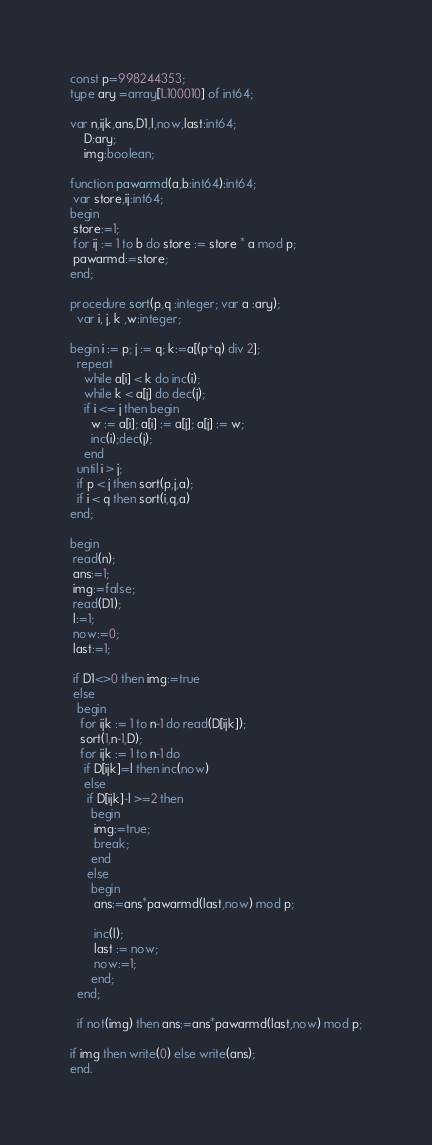Convert code to text. <code><loc_0><loc_0><loc_500><loc_500><_Pascal_>const p=998244353;
type ary =array[1..100010] of int64;
     
var n,ijk,ans,D1,l,now,last:int64;
    D:ary;
    img:boolean;
    
function pawarmd(a,b:int64):int64;
 var store,ij:int64;
begin
 store:=1;
 for ij := 1 to b do store := store * a mod p;
 pawarmd:=store;
end;
    
procedure sort(p,q :integer; var a :ary);
  var i, j, k ,w:integer;
      
begin i := p; j := q; k:=a[(p+q) div 2];
  repeat
    while a[i] < k do inc(i);
    while k < a[j] do dec(j);
    if i <= j then begin
      w := a[i]; a[i] := a[j]; a[j] := w;
      inc(i);dec(j);
    end
  until i > j;
  if p < j then sort(p,j,a);
  if i < q then sort(i,q,a)
end;   
       
begin
 read(n);
 ans:=1;
 img:=false;
 read(D1);
 l:=1;
 now:=0;
 last:=1;
 
 if D1<>0 then img:=true
 else
  begin
   for ijk := 1 to n-1 do read(D[ijk]);
   sort(1,n-1,D);
   for ijk := 1 to n-1 do
    if D[ijk]=l then inc(now)
    else 
     if D[ijk]-l >=2 then
      begin
       img:=true;
       break;
      end
     else
      begin
       ans:=ans*pawarmd(last,now) mod p;
      
       inc(l);
       last := now;
       now:=1;
      end;
  end;
  
  if not(img) then ans:=ans*pawarmd(last,now) mod p;
 
if img then write(0) else write(ans);
end.</code> 